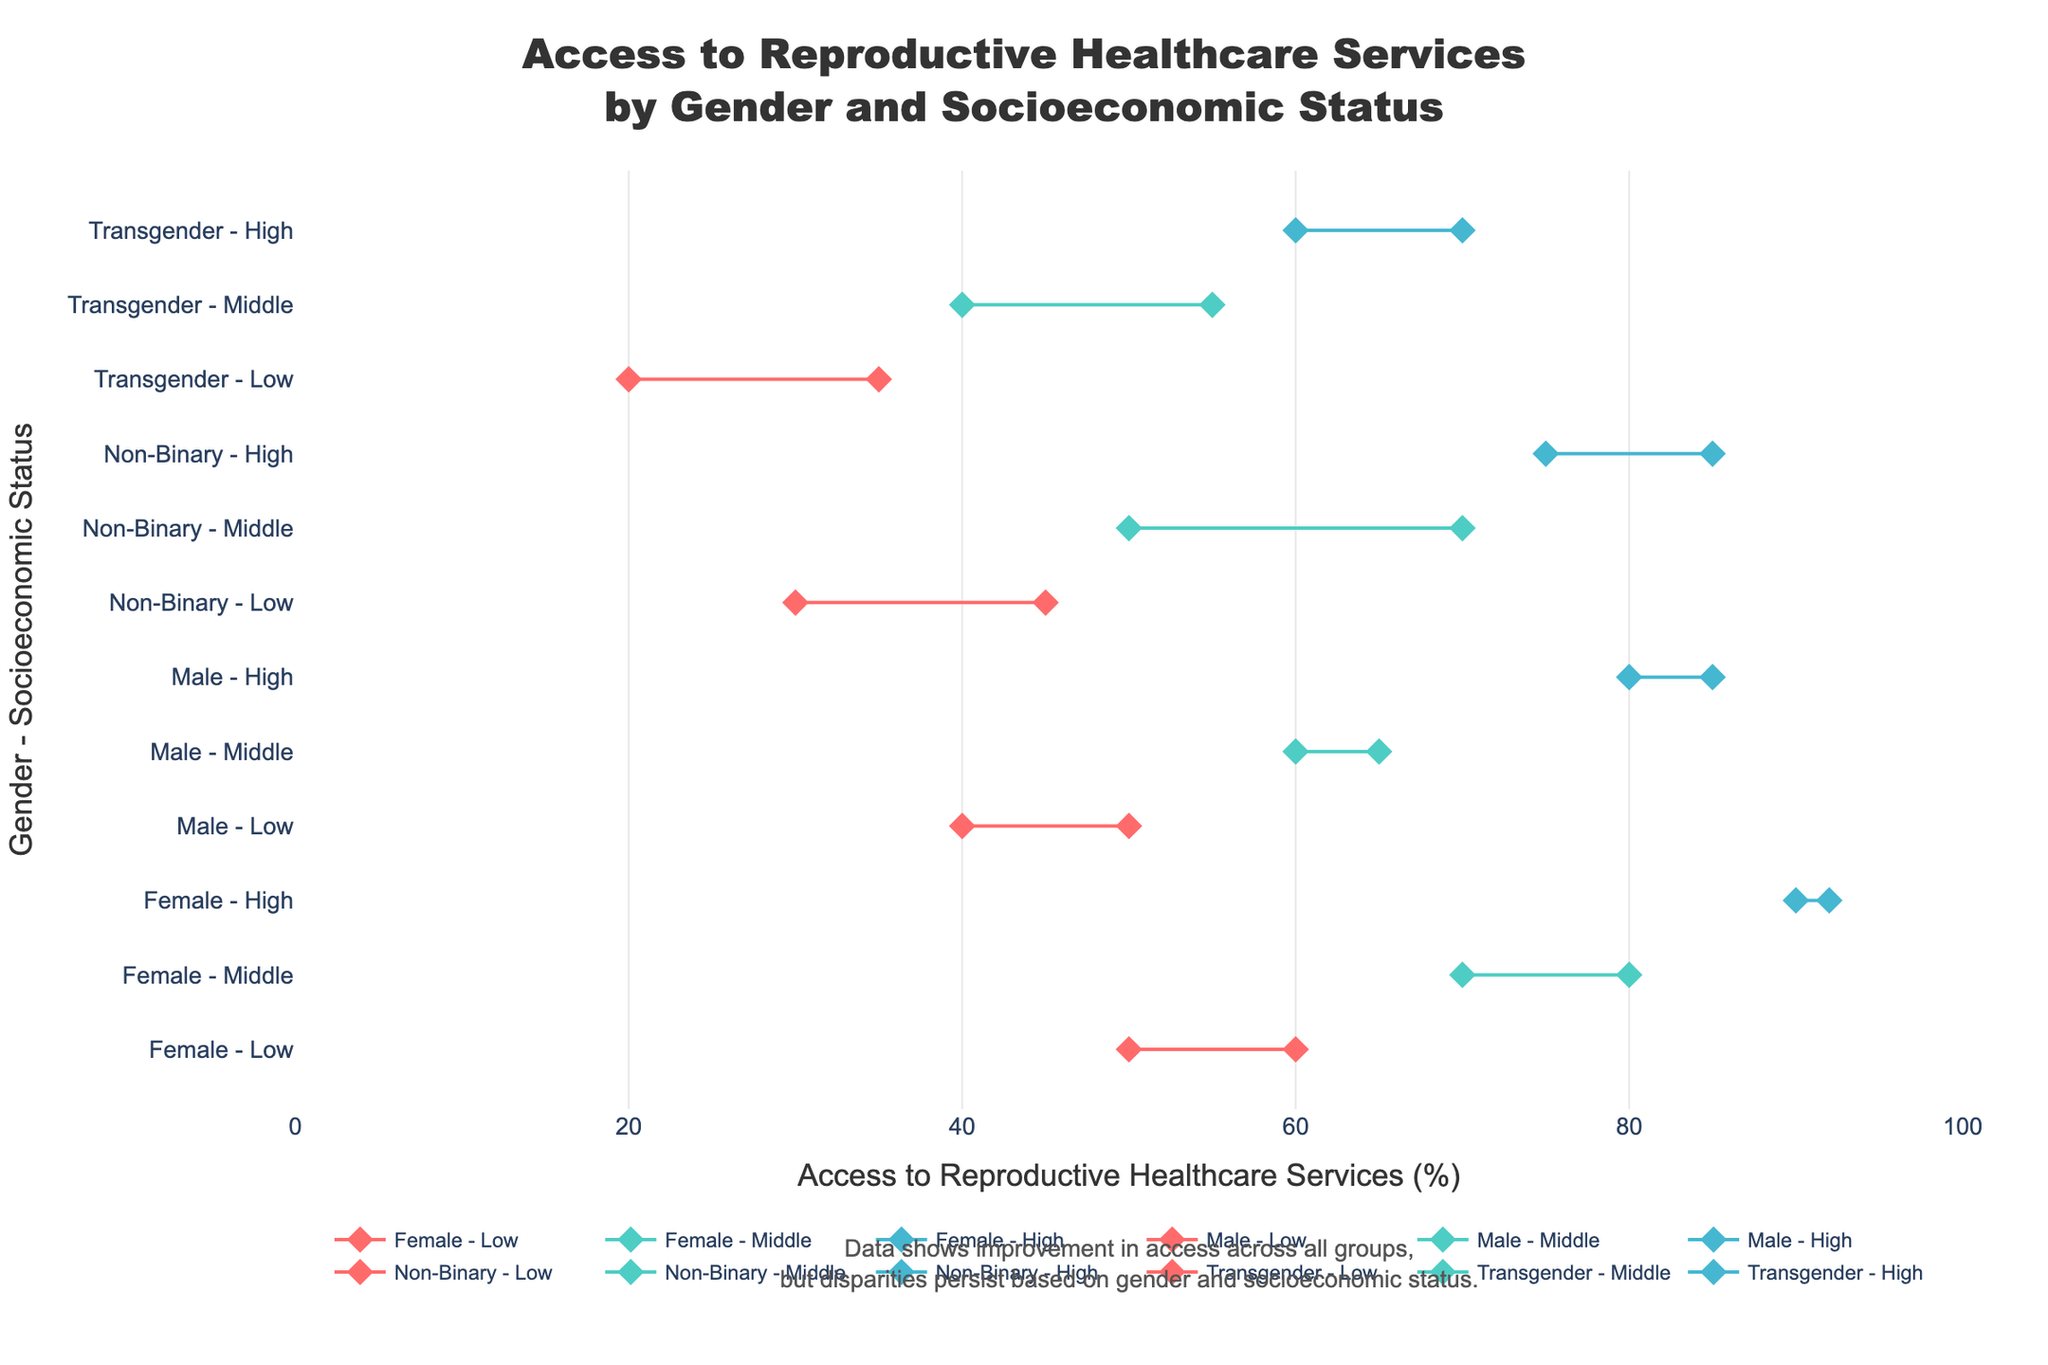What is the title of the plot? The title of the plot is displayed at the top center of the figure. It reads "Access to Reproductive Healthcare Services by Gender and Socioeconomic Status," indicating what the plot is about.
Answer: Access to Reproductive Healthcare Services by Gender and Socioeconomic Status Which gender-socioeconomic group saw the smallest increase in access to reproductive healthcare services? To determine the smallest increase, look at the difference between the 'before' and 'after' values for each group. The Female - High group increased from 90 to 92, which is a change of 2 units, the smallest increase among all groups.
Answer: Female - High What were the access percentages before and after improvements for transgender individuals in the middle socioeconomic status? Locate the markers for the "Transgender - Middle" group. The access percentages are 40% before and 55% after the improvements.
Answer: 40%, 55% Which socioeconomic status group among males had the highest access percentage after improvements? Identify the "Male" rows and compare the "Access to Reproductive Healthcare Services (After)" values. The High socioeconomic status group had the highest access at 85%.
Answer: High What is the overall trend shown in the plot? The plot demonstrates an overall trend of improvement in access to reproductive healthcare services across different genders and socioeconomic statuses, with lines connecting 'before' and 'after' points, generally trending upward.
Answer: Improvement in access Compare the access change between non-binary individuals in the low and middle socioeconomic statuses. Which group had a larger change? For Non-Binary - Low, the change is from 30% to 45%, which is an increase of 15 units. For Non-Binary - Middle, the change is from 50% to 70%, an increase of 20 units. Therefore, the Non-Binary - Middle group had a larger change.
Answer: Non-Binary - Middle What is the color used to represent the middle socioeconomic status groups? The middle socioeconomic status groups are represented with the color turquoise.
Answer: Turquoise What was the initial access level for males in the low socioeconomic status? Find the "Male - Low" group on the y-axis and look at the first marker positioned near the x-axis. The initial access level was at 40%.
Answer: 40% Which gender saw the highest access percentage improvement in the low socioeconomic status group? Among the Low socioeconomic status groups, compare the improvements for Female, Male, Non-Binary, and Transgender. The Non-Binary group improved from 30% to 45%, a 15-unit increase, which is the highest improvement.
Answer: Non-Binary Is there any group that didn't see at least a 5% improvement in access? Compare each group's 'before' and 'after' values. The Female - High group shows an improvement from 90% to 92%, which is only a 2% increase, less than 5%.
Answer: Female - High 